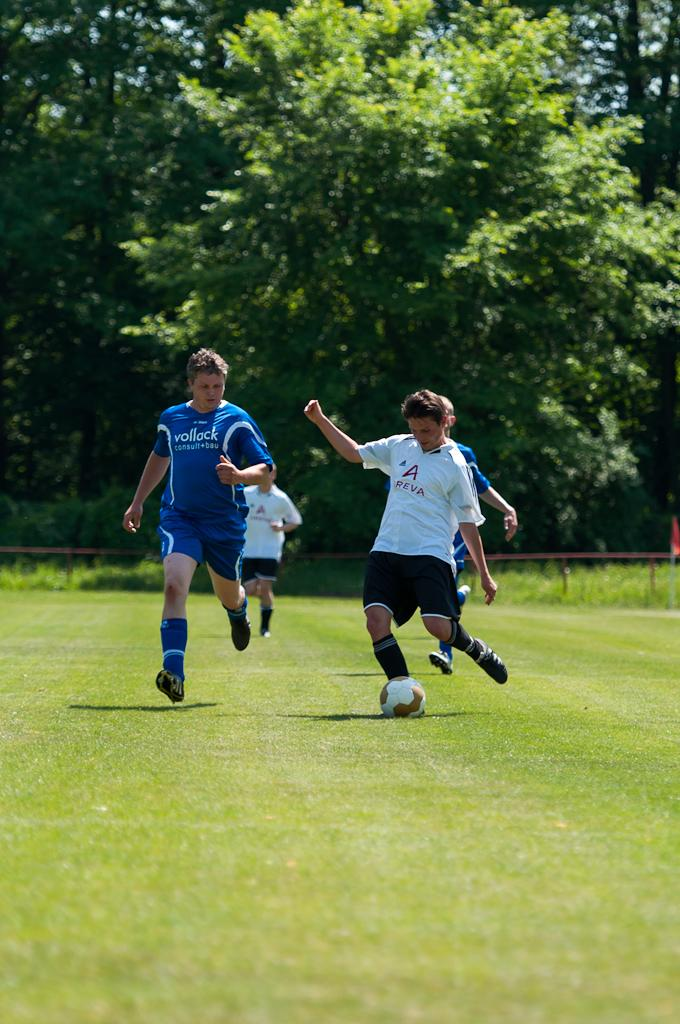What are the persons in the image doing? There is a group of persons running in the image. What is the person in the foreground doing? The person is kicking a ball in the ground. What can be seen in the background of the image? There is a tree, sky, an iron rod, and a red color flag visible in the background of the image. What type of muscle can be seen flexing in the image? There is no muscle flexing visible in the image; it features a group of persons running and a person kicking a ball. What taste can be experienced from the red color flag in the image? There is no taste associated with the red color flag in the image; it is a visual element. 